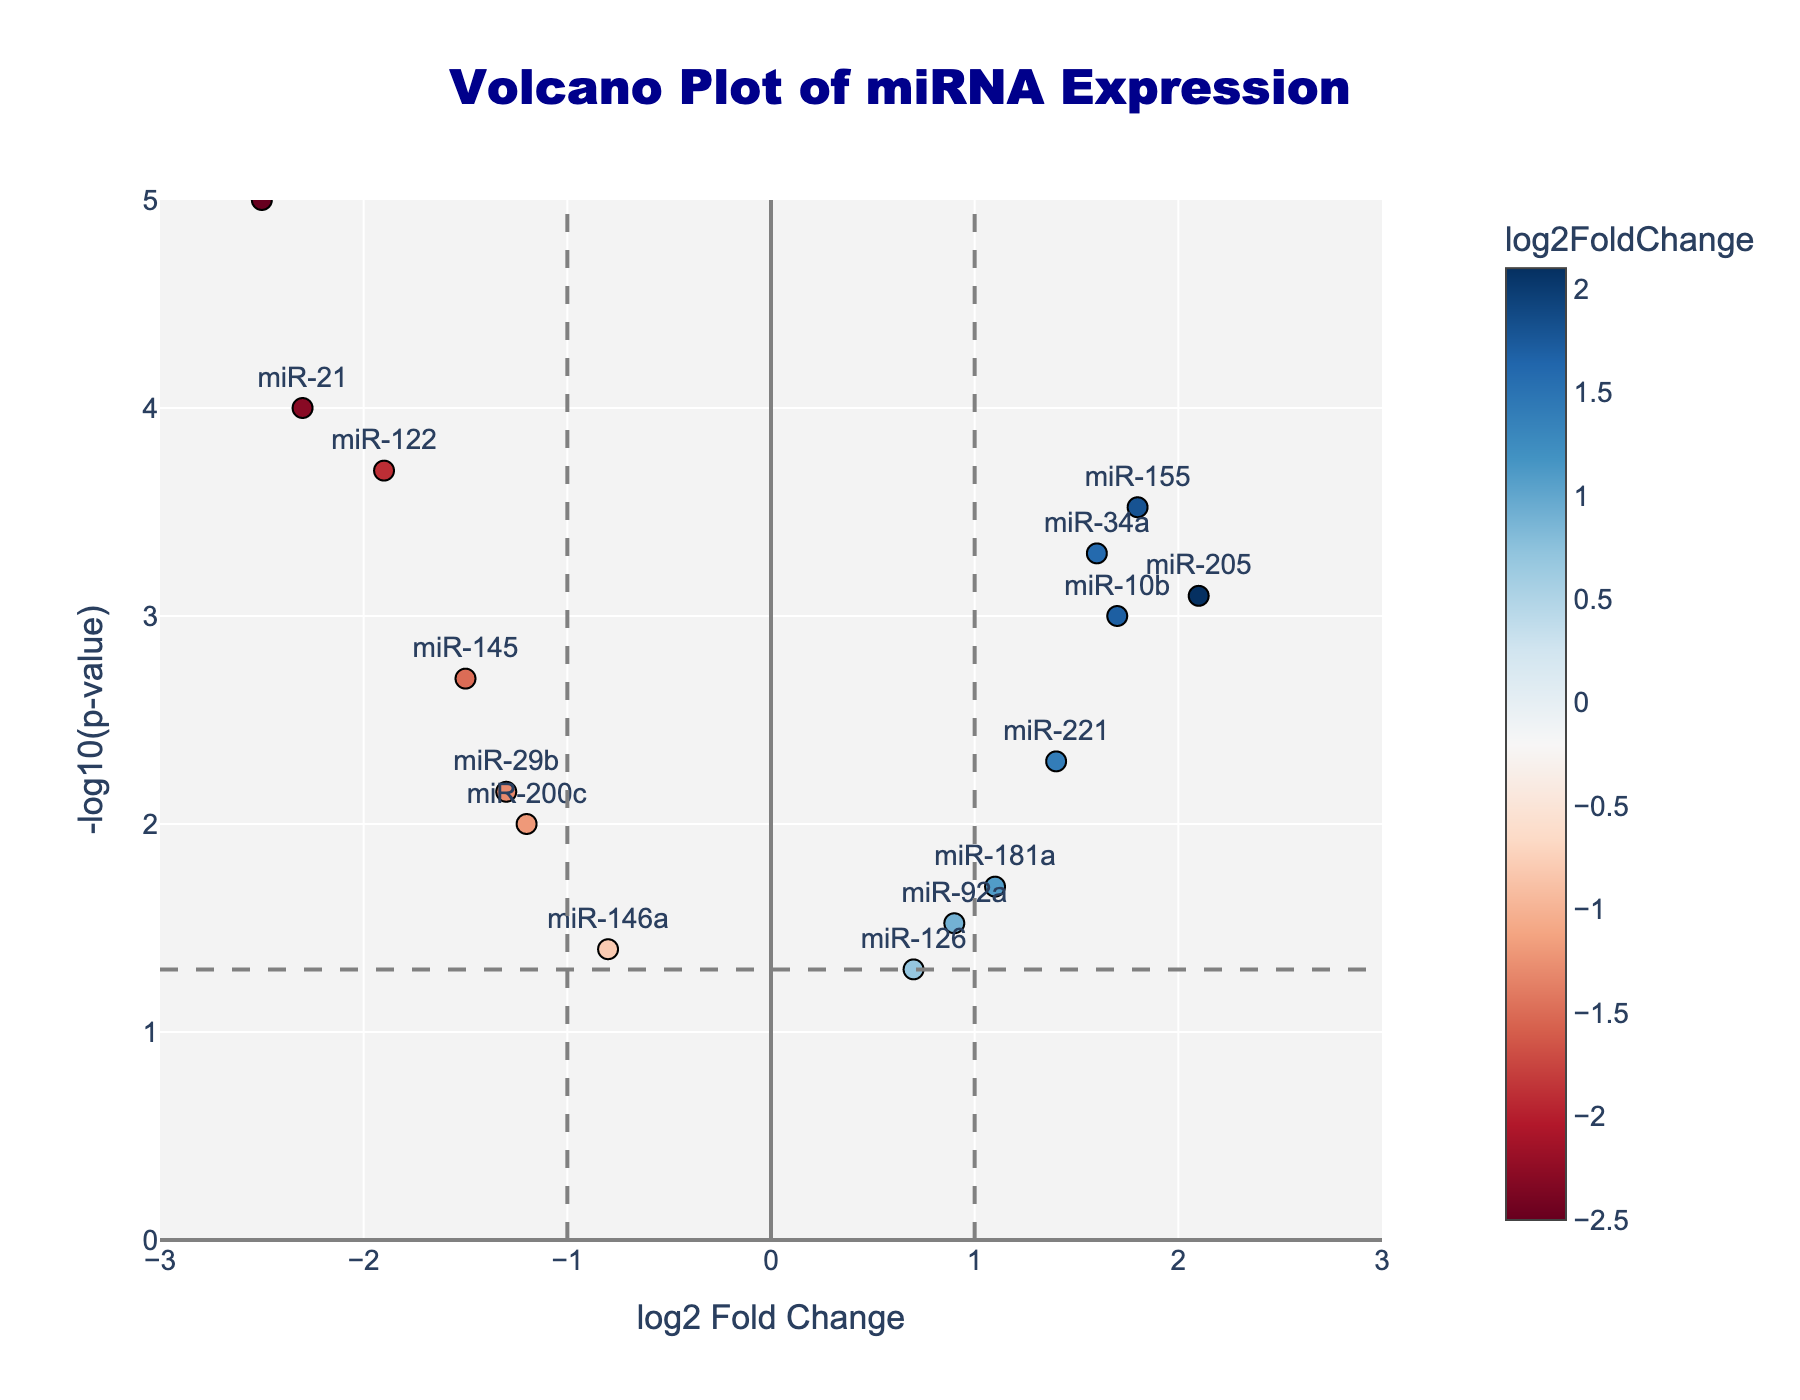How many miRNAs are represented in the plot? There are 15 miRNAs listed in the provided dataset. Each miRNA corresponds to a data point in the plot, identified by the text labels.
Answer: 15 What does the color of the data points represent? The color of the data points represents the log2 fold change value. A color scale bar on the side indicates that blue represents negative values, red represents positive values, and gradients in between indicate intermediate values.
Answer: log2 fold change What does a high value on the y-axis indicate? The y-axis represents -log10(p-value). A higher value on the y-axis indicates a more statistically significant p-value (a smaller p-value).
Answer: High statistical significance How many miRNAs are outside the threshold lines of log2 fold change? Threshold lines are drawn at -1 and 1 on the x-axis. Count the points outside these lines. miR-21, miR-155, miR-205, miR-34a, miR-375, miR-10b, and miR-122 are outside, making a total of 7 miRNAs.
Answer: 7 Which miRNA has the lowest p-value? The lowest p-value corresponds to the highest value on the y-axis (-log10(p-value)). This is miR-375 with a -log10(p-value) significantly higher than others.
Answer: miR-375 How many miRNAs show a significant downregulation in diseased tissue compared to healthy tissue? Significant downregulation means negative log2 fold change and high -log10(p-value). Points to the left side of the vertical line at x = -1 and above the horizontal line at y = 1.3 are miR-21, miR-145, miR-122, and miR-375.
Answer: 4 Which miRNA has the highest expression increase in diseased tissue compared to healthy tissue? The highest expression increase is indicated by the highest positive log2 fold change value. On the right side, miR-205 has the highest log2 fold change value.
Answer: miR-205 Which miRNAs lie within both the log2 fold change thresholds and the p-value threshold? Within both thresholds means the points inside vertical lines x = -1 to 1 and above the horizontal line y = 1.3 are miR-221 and miR-181a.
Answer: miR-221 and miR-181a Which miRNA has the smallest expression change yet passes the significance threshold? The smallest expression change will be closest to 0 on the x-axis but must also be above the p-value threshold line at y = 1.3. This miRNA is miR-10b.
Answer: miR-10b Do any miRNAs not pass the significance threshold? Points below the horizontal threshold at y=1.3 are miR-126, miR-146a, and miR-92a.
Answer: miR-126, miR-146a, and miR-92a 